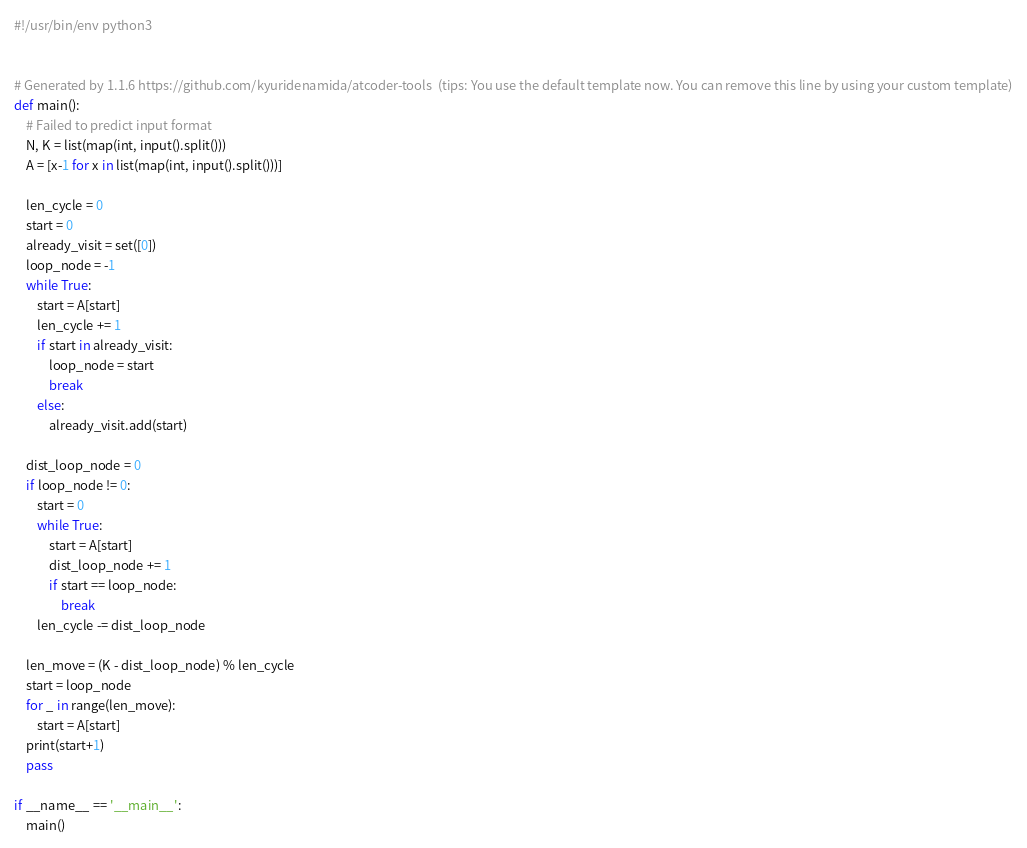Convert code to text. <code><loc_0><loc_0><loc_500><loc_500><_Python_>#!/usr/bin/env python3


# Generated by 1.1.6 https://github.com/kyuridenamida/atcoder-tools  (tips: You use the default template now. You can remove this line by using your custom template)
def main():
    # Failed to predict input format
    N, K = list(map(int, input().split()))
    A = [x-1 for x in list(map(int, input().split()))]

    len_cycle = 0
    start = 0
    already_visit = set([0])
    loop_node = -1
    while True:
        start = A[start]
        len_cycle += 1
        if start in already_visit:
            loop_node = start
            break
        else:
            already_visit.add(start)

    dist_loop_node = 0
    if loop_node != 0:
        start = 0
        while True:
            start = A[start]
            dist_loop_node += 1
            if start == loop_node:
                break
        len_cycle -= dist_loop_node

    len_move = (K - dist_loop_node) % len_cycle
    start = loop_node
    for _ in range(len_move):
        start = A[start]
    print(start+1)
    pass

if __name__ == '__main__':
    main()</code> 